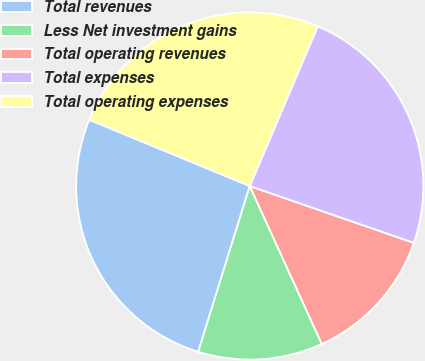Convert chart to OTSL. <chart><loc_0><loc_0><loc_500><loc_500><pie_chart><fcel>Total revenues<fcel>Less Net investment gains<fcel>Total operating revenues<fcel>Total expenses<fcel>Total operating expenses<nl><fcel>26.43%<fcel>11.61%<fcel>12.88%<fcel>23.9%<fcel>25.17%<nl></chart> 